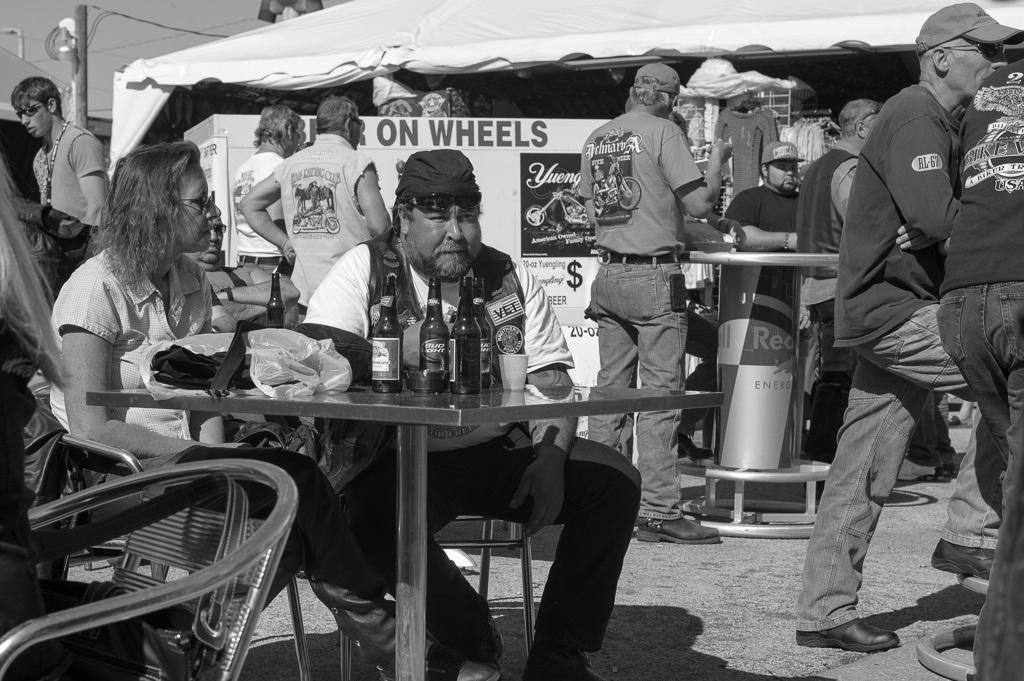Can you describe this image briefly? There is a group of people. Some persons are standing and some persons are sitting on a chairs. There is a table on the left side. There is a bottle,glass,cover on a table. There is an another table on the right side. we can see in the background tent,banner,pole and light. 